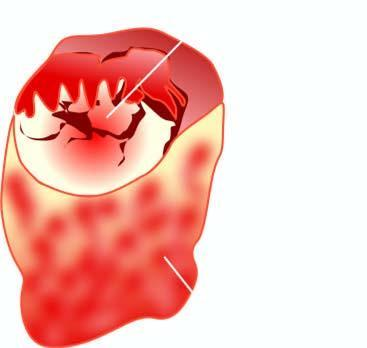does icroscopic appearance of loss of nuclear polarity b show a single nodule separated from the rest of thyroid parenchyma by incomplete fibrous septa?
Answer the question using a single word or phrase. No 